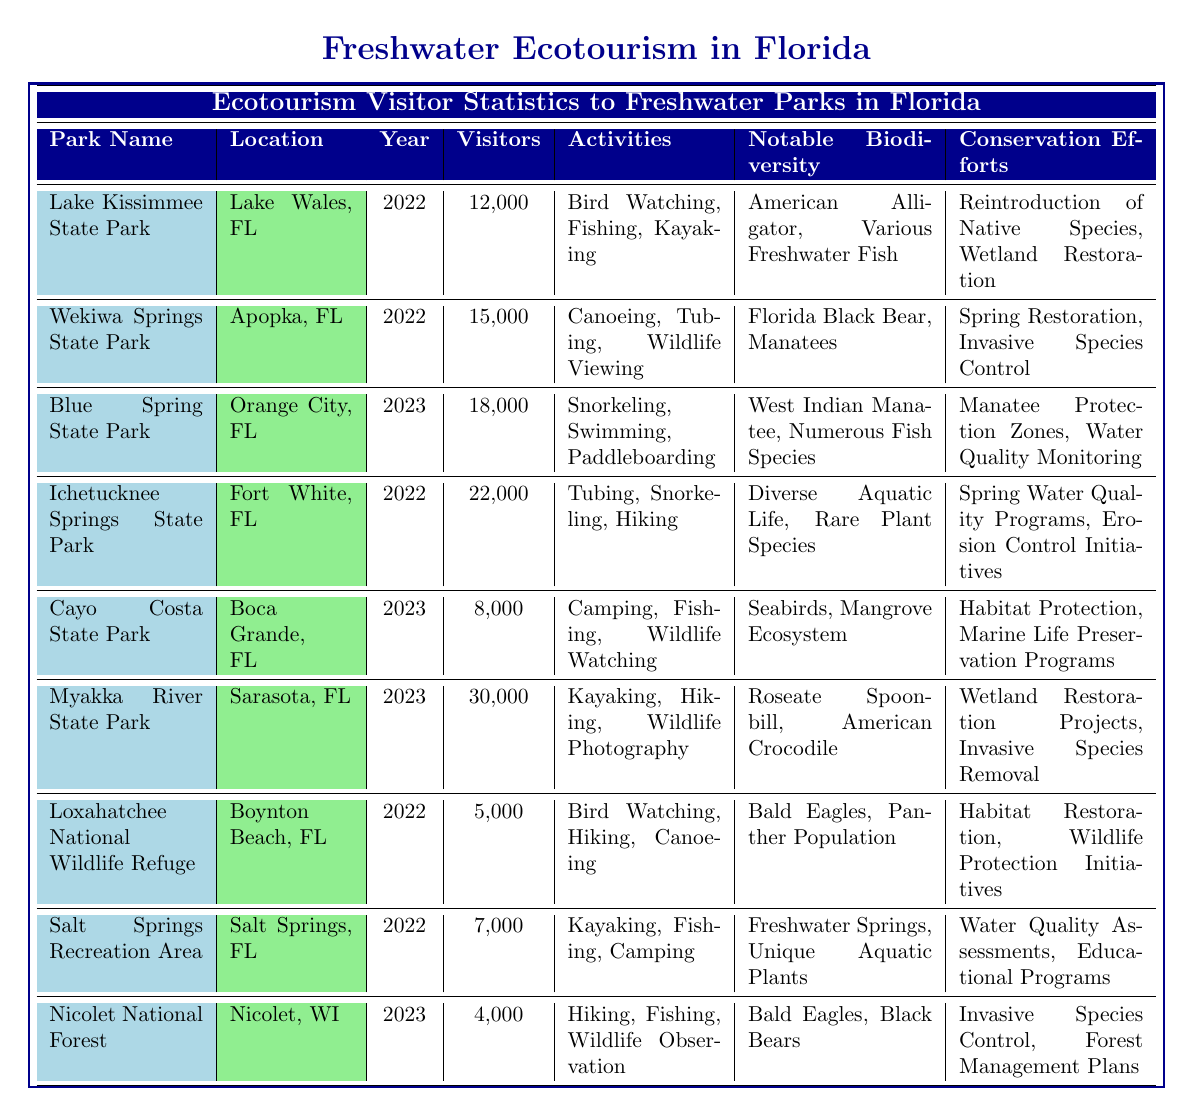What is the visitor count for Myakka River State Park in 2023? The table indicates that Myakka River State Park had a visitor count of 30,000 in 2023.
Answer: 30,000 How many activities are offered at Ichetucknee Springs State Park? According to the table, Ichetucknee Springs State Park offers three activities: Tubing, Snorkeling, and Hiking.
Answer: 3 Which park had the highest visitor count in 2022? By comparing the visitor counts for 2022, Ichetucknee Springs State Park had the highest count with 22,000 visitors.
Answer: Ichetucknee Springs State Park What is the total number of visitors to all parks listed in 2023? The visitor counts for the parks in 2023 are summed as follows: 18,000 (Blue Spring State Park) + 8,000 (Cayo Costa State Park) + 30,000 (Myakka River State Park) + 4,000 (Nicolet National Forest) = 60,000 visitors in total.
Answer: 60,000 Does Lake Kissimmee State Park offer fishing as an activity? The table shows that Lake Kissimmee State Park lists Fishing as one of the activities offered.
Answer: Yes Which parks had visitor counts of less than 10,000 in 2022? Cross-referencing the visitor counts for 2022, the parks with less than 10,000 visitors are Loxahatchee National Wildlife Refuge (5,000) and Salt Springs Recreation Area (7,000).
Answer: Loxahatchee National Wildlife Refuge, Salt Springs Recreation Area What is the average number of visitors for all parks in 2022? In 2022, the visitor counts are 12,000 (Lake Kissimmee State Park), 15,000 (Wekiwa Springs State Park), 22,000 (Ichetucknee Springs State Park), 5,000 (Loxahatchee National Wildlife Refuge), and 7,000 (Salt Springs Recreation Area). The total visitor count is 61,000, so the average is 61,000 divided by 5 (the number of parks) = 12,200.
Answer: 12,200 Which park had the largest biodiversity noted and what are they? The park with the most notable biodiversity is Myakka River State Park, which notes the Roseate Spoonbill and the American Crocodile.
Answer: Myakka River State Park; Roseate Spoonbill, American Crocodile How many parks were visited in 2023? The table lists four parks that had visitor counts in 2023: Blue Spring State Park, Cayo Costa State Park, Myakka River State Park, and Nicolet National Forest, making a total of four parks.
Answer: 4 What conservation effort is common between Blue Spring State Park and Myakka River State Park? Both parks include conservation efforts related to monitoring or protection, specifically, Blue Spring State Park mentions "Water Quality Monitoring" and Myakka River State Park has "Wetland Restoration Projects."
Answer: Water Quality Monitoring and Wetland Restoration 